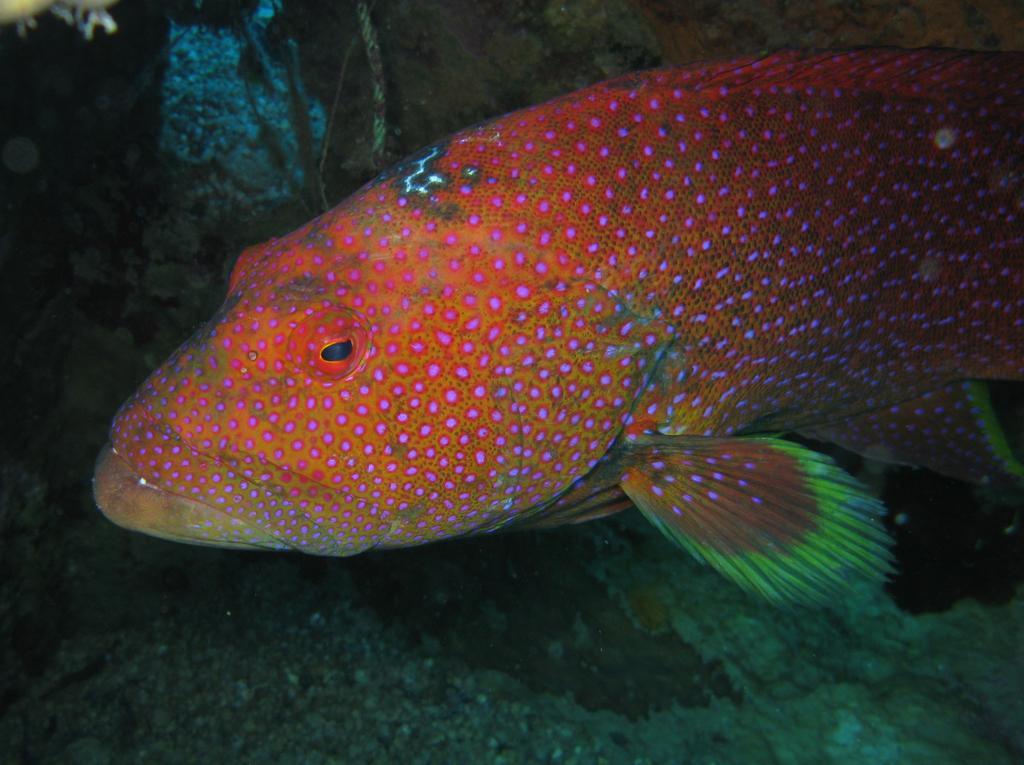How would you summarize this image in a sentence or two? In this picture we can see a fish and some objects in the water. 